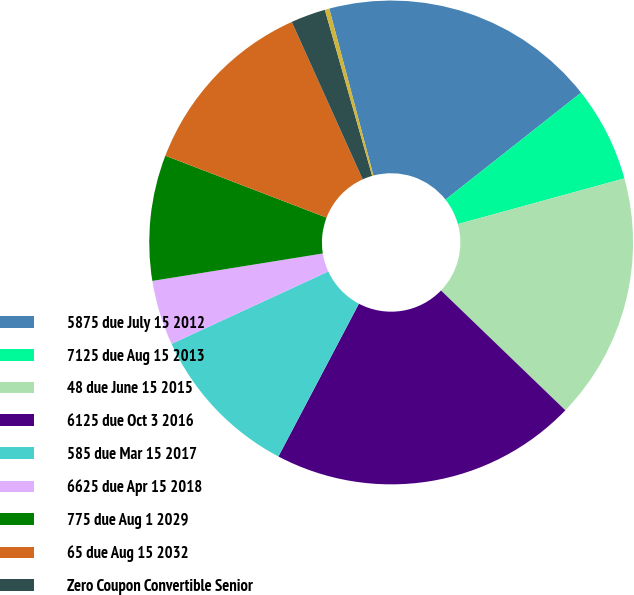Convert chart. <chart><loc_0><loc_0><loc_500><loc_500><pie_chart><fcel>5875 due July 15 2012<fcel>7125 due Aug 15 2013<fcel>48 due June 15 2015<fcel>6125 due Oct 3 2016<fcel>585 due Mar 15 2017<fcel>6625 due Apr 15 2018<fcel>775 due Aug 1 2029<fcel>65 due Aug 15 2032<fcel>Zero Coupon Convertible Senior<fcel>Other<nl><fcel>18.49%<fcel>6.36%<fcel>16.47%<fcel>20.51%<fcel>10.4%<fcel>4.34%<fcel>8.38%<fcel>12.42%<fcel>2.32%<fcel>0.3%<nl></chart> 